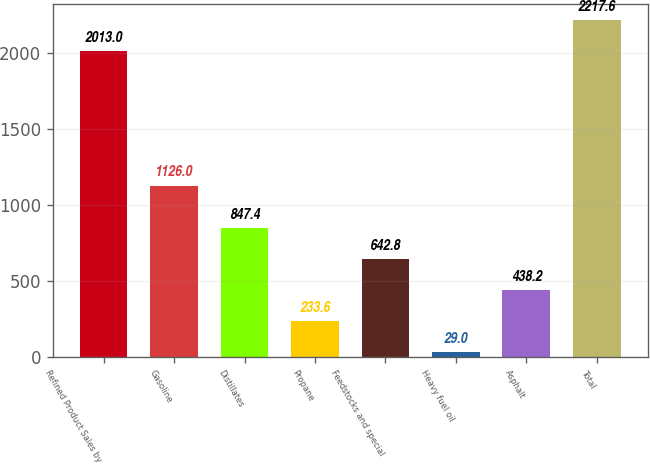Convert chart to OTSL. <chart><loc_0><loc_0><loc_500><loc_500><bar_chart><fcel>Refined Product Sales by<fcel>Gasoline<fcel>Distillates<fcel>Propane<fcel>Feedstocks and special<fcel>Heavy fuel oil<fcel>Asphalt<fcel>Total<nl><fcel>2013<fcel>1126<fcel>847.4<fcel>233.6<fcel>642.8<fcel>29<fcel>438.2<fcel>2217.6<nl></chart> 